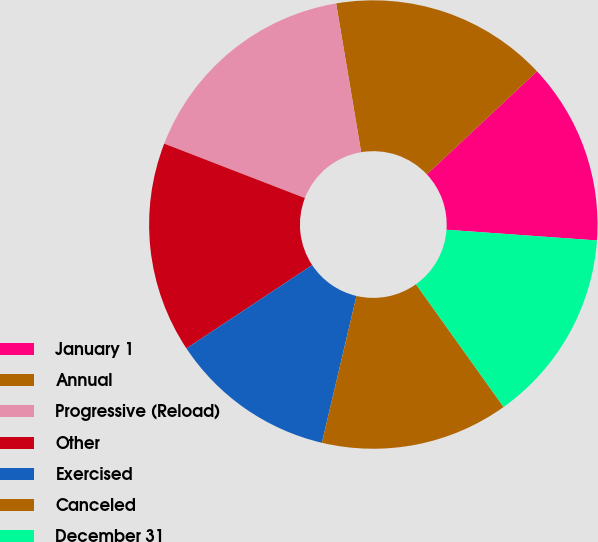<chart> <loc_0><loc_0><loc_500><loc_500><pie_chart><fcel>January 1<fcel>Annual<fcel>Progressive (Reload)<fcel>Other<fcel>Exercised<fcel>Canceled<fcel>December 31<nl><fcel>13.11%<fcel>15.67%<fcel>16.47%<fcel>15.19%<fcel>12.0%<fcel>13.55%<fcel>14.0%<nl></chart> 